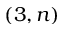<formula> <loc_0><loc_0><loc_500><loc_500>( 3 , n )</formula> 